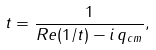Convert formula to latex. <formula><loc_0><loc_0><loc_500><loc_500>t = \frac { 1 } { R e ( 1 / t ) - i \, q _ { c m } } ,</formula> 